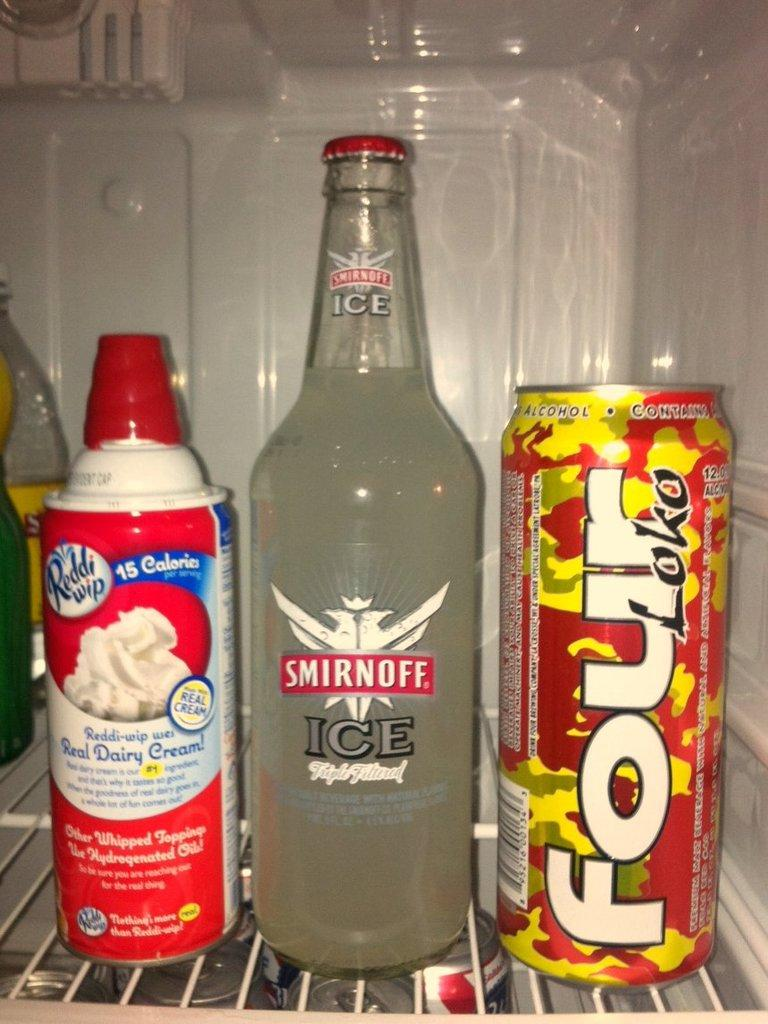<image>
Create a compact narrative representing the image presented. A bottle of Smirnoff Ice is in the fridge next to a can of Four loko. 